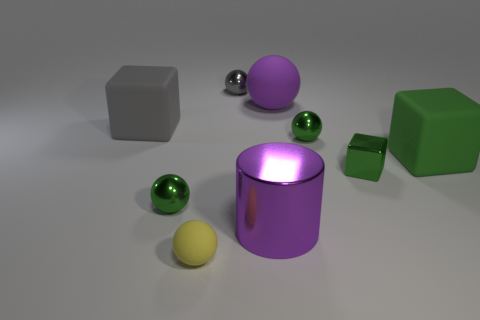Is there a large gray thing made of the same material as the large gray block?
Provide a succinct answer. No. There is a purple shiny thing; is its shape the same as the green metallic object behind the big green matte cube?
Make the answer very short. No. What number of objects are behind the shiny cylinder and in front of the small gray thing?
Offer a terse response. 6. Is the gray ball made of the same material as the gray object that is in front of the gray shiny object?
Offer a terse response. No. Is the number of rubber blocks that are left of the purple cylinder the same as the number of tiny yellow objects?
Offer a terse response. Yes. What color is the rubber object that is on the left side of the small yellow ball?
Provide a succinct answer. Gray. How many other objects are there of the same color as the tiny block?
Your answer should be very brief. 3. Is there any other thing that is the same size as the green metallic cube?
Offer a very short reply. Yes. Is the size of the green metallic sphere that is to the left of the yellow thing the same as the big cylinder?
Offer a very short reply. No. There is a big gray object that is behind the big cylinder; what is it made of?
Your answer should be very brief. Rubber. 